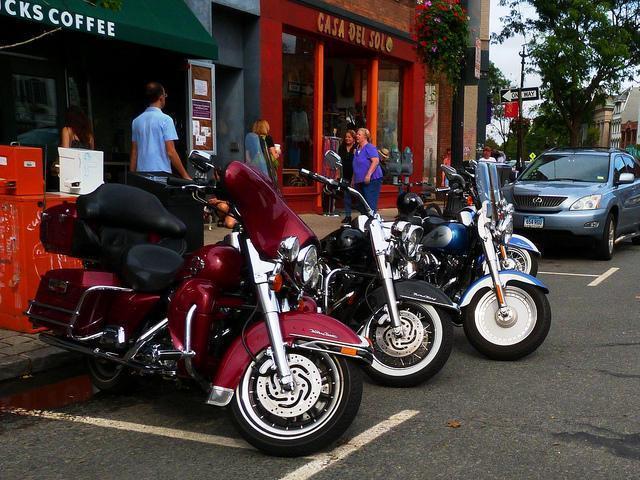What is the parent organization of the SUV?
Select the correct answer and articulate reasoning with the following format: 'Answer: answer
Rationale: rationale.'
Options: Ford, toyota, honda, ferrari. Answer: toyota.
Rationale: The organization is toyota. 